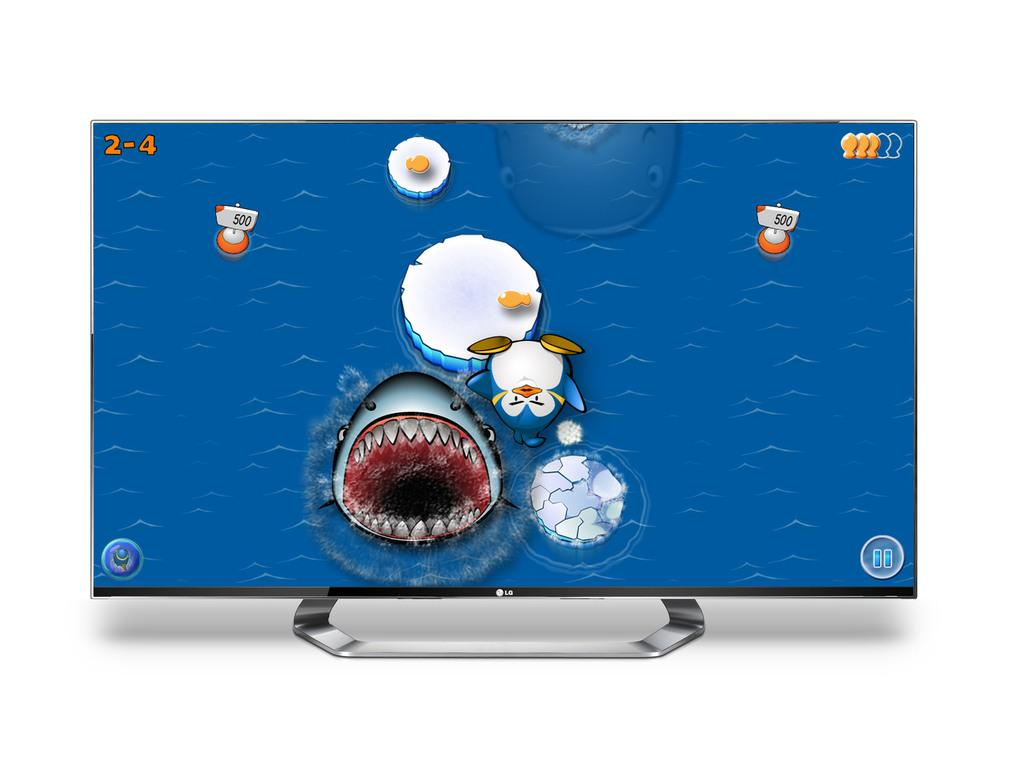<image>
Offer a succinct explanation of the picture presented. The screen shows a shark and numbers 2-4 on the screen like a score 